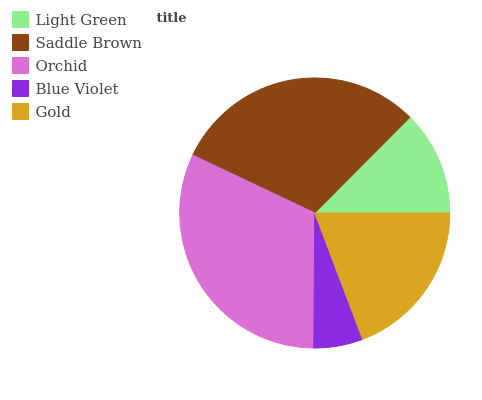Is Blue Violet the minimum?
Answer yes or no. Yes. Is Orchid the maximum?
Answer yes or no. Yes. Is Saddle Brown the minimum?
Answer yes or no. No. Is Saddle Brown the maximum?
Answer yes or no. No. Is Saddle Brown greater than Light Green?
Answer yes or no. Yes. Is Light Green less than Saddle Brown?
Answer yes or no. Yes. Is Light Green greater than Saddle Brown?
Answer yes or no. No. Is Saddle Brown less than Light Green?
Answer yes or no. No. Is Gold the high median?
Answer yes or no. Yes. Is Gold the low median?
Answer yes or no. Yes. Is Orchid the high median?
Answer yes or no. No. Is Saddle Brown the low median?
Answer yes or no. No. 